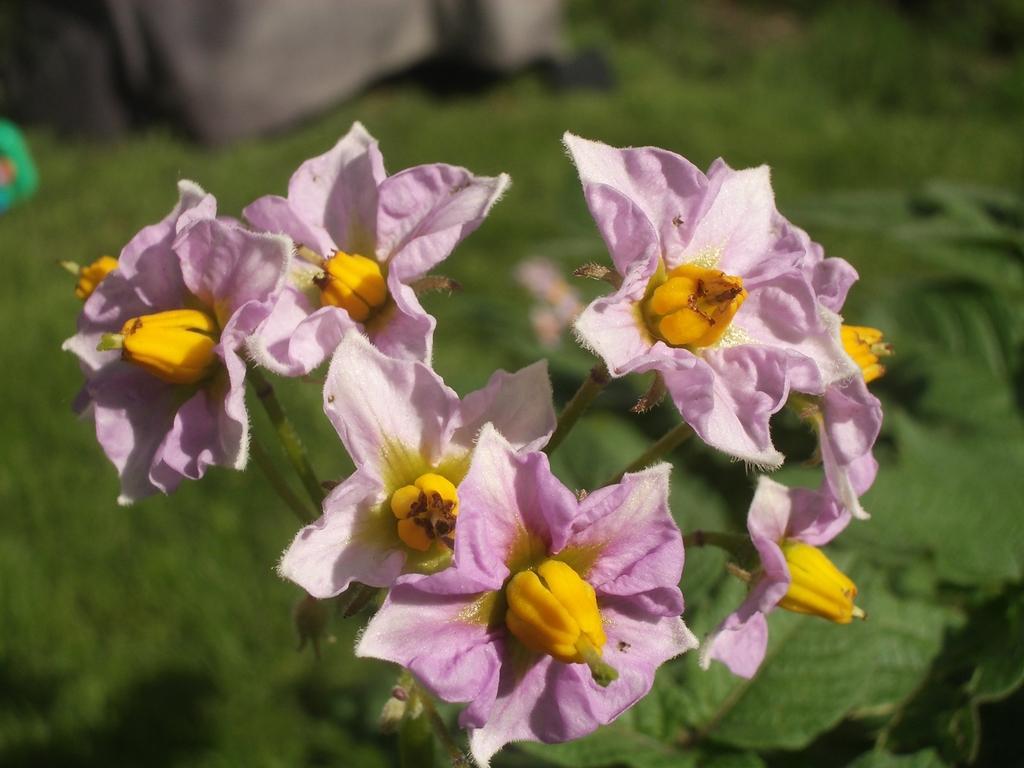How would you summarize this image in a sentence or two? In this image we can see pink color flowers and we can see the greenery in the background. 